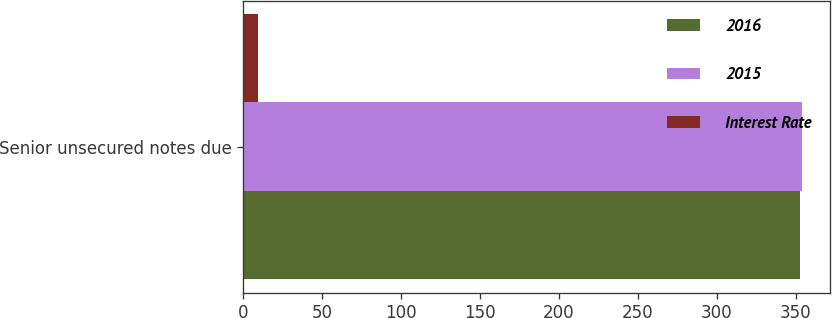Convert chart. <chart><loc_0><loc_0><loc_500><loc_500><stacked_bar_chart><ecel><fcel>Senior unsecured notes due<nl><fcel>2016<fcel>353<nl><fcel>2015<fcel>354<nl><fcel>Interest Rate<fcel>9.12<nl></chart> 